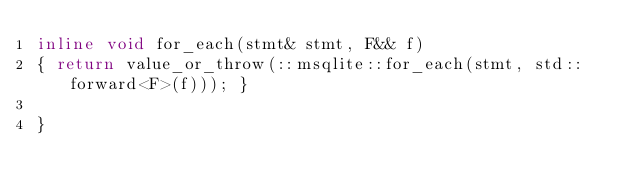Convert code to text. <code><loc_0><loc_0><loc_500><loc_500><_C++_>inline void for_each(stmt& stmt, F&& f)
{ return value_or_throw(::msqlite::for_each(stmt, std::forward<F>(f))); }

}
</code> 